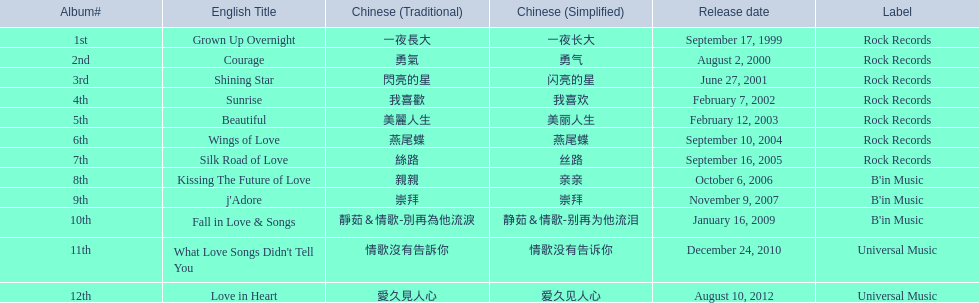What were the album titles? Grown Up Overnight, Courage, Shining Star, Sunrise, Beautiful, Wings of Love, Silk Road of Love, Kissing The Future of Love, j'Adore, Fall in Love & Songs, What Love Songs Didn't Tell You, Love in Heart. Parse the full table. {'header': ['Album#', 'English Title', 'Chinese (Traditional)', 'Chinese (Simplified)', 'Release date', 'Label'], 'rows': [['1st', 'Grown Up Overnight', '一夜長大', '一夜长大', 'September 17, 1999', 'Rock Records'], ['2nd', 'Courage', '勇氣', '勇气', 'August 2, 2000', 'Rock Records'], ['3rd', 'Shining Star', '閃亮的星', '闪亮的星', 'June 27, 2001', 'Rock Records'], ['4th', 'Sunrise', '我喜歡', '我喜欢', 'February 7, 2002', 'Rock Records'], ['5th', 'Beautiful', '美麗人生', '美丽人生', 'February 12, 2003', 'Rock Records'], ['6th', 'Wings of Love', '燕尾蝶', '燕尾蝶', 'September 10, 2004', 'Rock Records'], ['7th', 'Silk Road of Love', '絲路', '丝路', 'September 16, 2005', 'Rock Records'], ['8th', 'Kissing The Future of Love', '親親', '亲亲', 'October 6, 2006', "B'in Music"], ['9th', "j'Adore", '崇拜', '崇拜', 'November 9, 2007', "B'in Music"], ['10th', 'Fall in Love & Songs', '靜茹＆情歌-別再為他流淚', '静茹＆情歌-别再为他流泪', 'January 16, 2009', "B'in Music"], ['11th', "What Love Songs Didn't Tell You", '情歌沒有告訴你', '情歌没有告诉你', 'December 24, 2010', 'Universal Music'], ['12th', 'Love in Heart', '愛久見人心', '爱久见人心', 'August 10, 2012', 'Universal Music']]} Among them, which were launched by b'in music? Kissing The Future of Love, j'Adore. From those, which one came out in an even-numbered year? Kissing The Future of Love. 